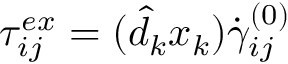<formula> <loc_0><loc_0><loc_500><loc_500>\begin{array} { r } { \tau _ { i j } ^ { e x } = ( \hat { d } _ { k } x _ { k } ) \dot { \gamma } _ { i j } ^ { ( 0 ) } } \end{array}</formula> 